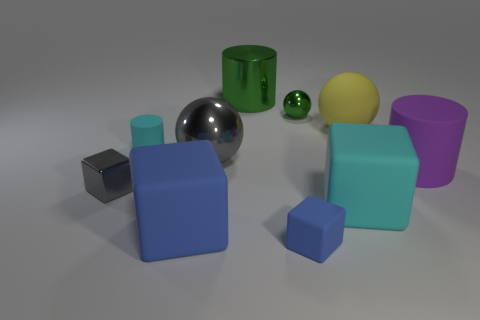Subtract all small cylinders. How many cylinders are left? 2 Subtract 2 spheres. How many spheres are left? 1 Subtract all blue things. Subtract all purple matte cylinders. How many objects are left? 7 Add 2 gray metallic objects. How many gray metallic objects are left? 4 Add 7 big metallic balls. How many big metallic balls exist? 8 Subtract all purple cylinders. How many cylinders are left? 2 Subtract 0 brown cubes. How many objects are left? 10 Subtract all balls. How many objects are left? 7 Subtract all brown balls. Subtract all cyan cylinders. How many balls are left? 3 Subtract all cyan spheres. How many blue cubes are left? 2 